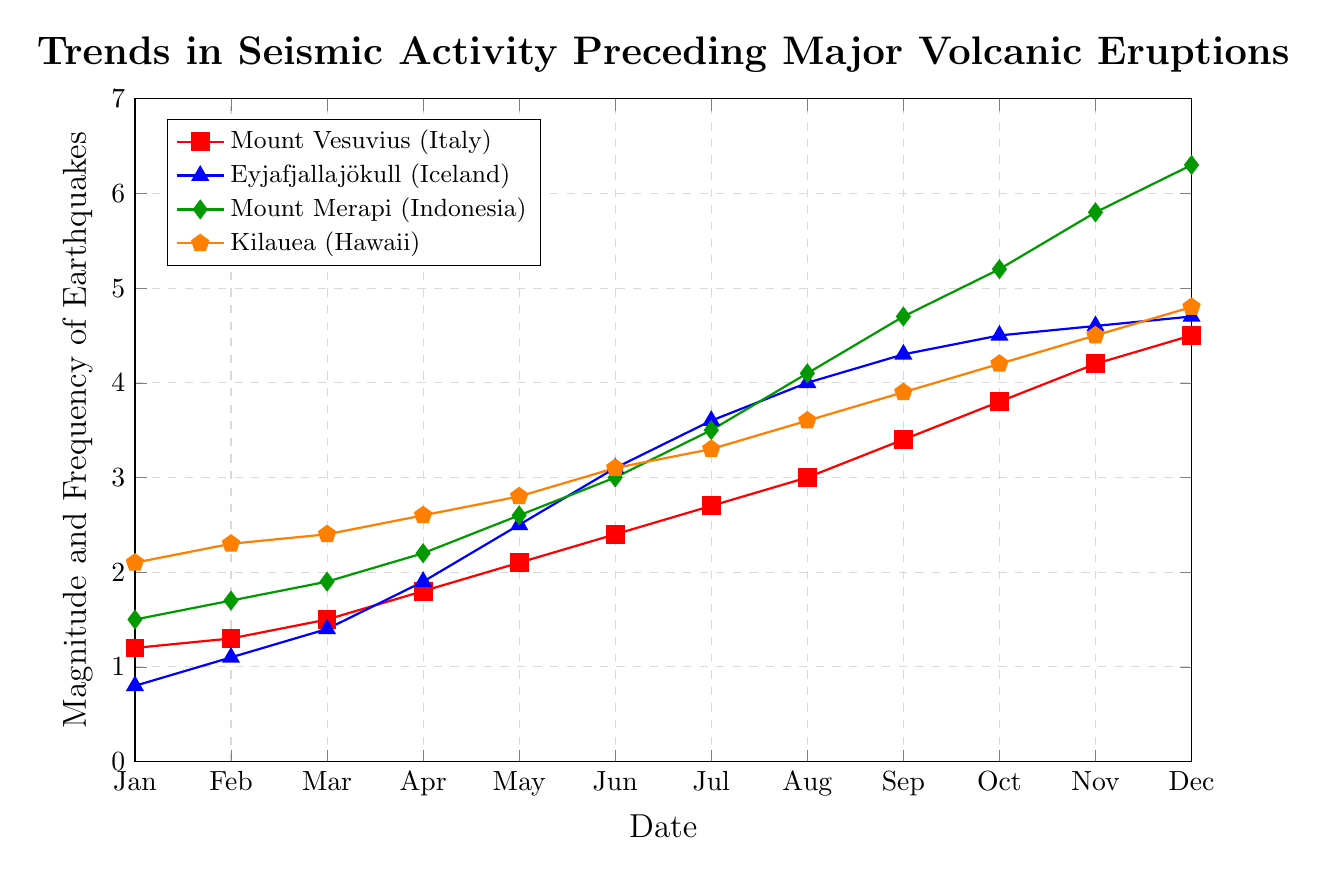What's the trend of seismic activity for Mount Vesuvius (Italy) from January to December? The seismic activity for Mount Vesuvius has shown a steady increase each month from January (1.2) to December (4.5).
Answer: Steady increase In which month did Eyjafjallajökull (Iceland) experience the most significant increase in seismic activity? Eyjafjallajökull experienced the most significant increase in seismic activity from April (1.9) to May (2.5), an increment of 0.6 units.
Answer: May Compared to Kilauea (Hawaii), which volcano had the highest seismic activity in December? In December, Mount Merapi (Indonesia) had a seismic activity of 6.3, which is higher than Kilauea’s 4.8.
Answer: Mount Merapi How does the seismic activity of Mount Merapi (Indonesia) in June compare to that of Eyjafjallajökull (Iceland) in the same month? In June, Mount Merapi recorded a seismic activity of 3.0, which is 0.1 less than Eyjafjallajökull’s 3.1.
Answer: Less Which volcano showed the most consistent month-to-month increase in seismic activity up to December? Kilauea (Hawaii) showed a consistent month-to-month increase in seismic activity from January (2.1) to December (4.8) without any decrease.
Answer: Kilauea Calculate the average increase in seismic activity per month for Mount Vesuvius (Italy) from January to December. To find the average increase: (4.5 - 1.2) / 11 = 3.3 / 11 ≈ 0.30. So, the average increase per month is approximately 0.30 units.
Answer: 0.30 units per month Which volcano had the lowest seismic activity in March and what was the value? In March, Eyjafjallajökull (Iceland) had the lowest seismic activity, recorded at 1.4.
Answer: Eyjafjallajökull, 1.4 What is the total rise in seismic activity for Mount Merapi (Indonesia) over the year? The total rise from January (1.5) to December (6.3) is 6.3 - 1.5 = 4.8.
Answer: 4.8 Describe the visual difference in seismic activity trends between Mount Merapi (Indonesia) and Eyjafjallajökull (Iceland). Mount Merapi shows a sharp upward trend with seismic activity reaching the highest among all by December at 6.3, while Eyjafjallajökull shows a less steep but steady rise peaking at 4.7 in December.
Answer: Mount Merapi: sharp rise, Eyjafjallajökull: steady rise 